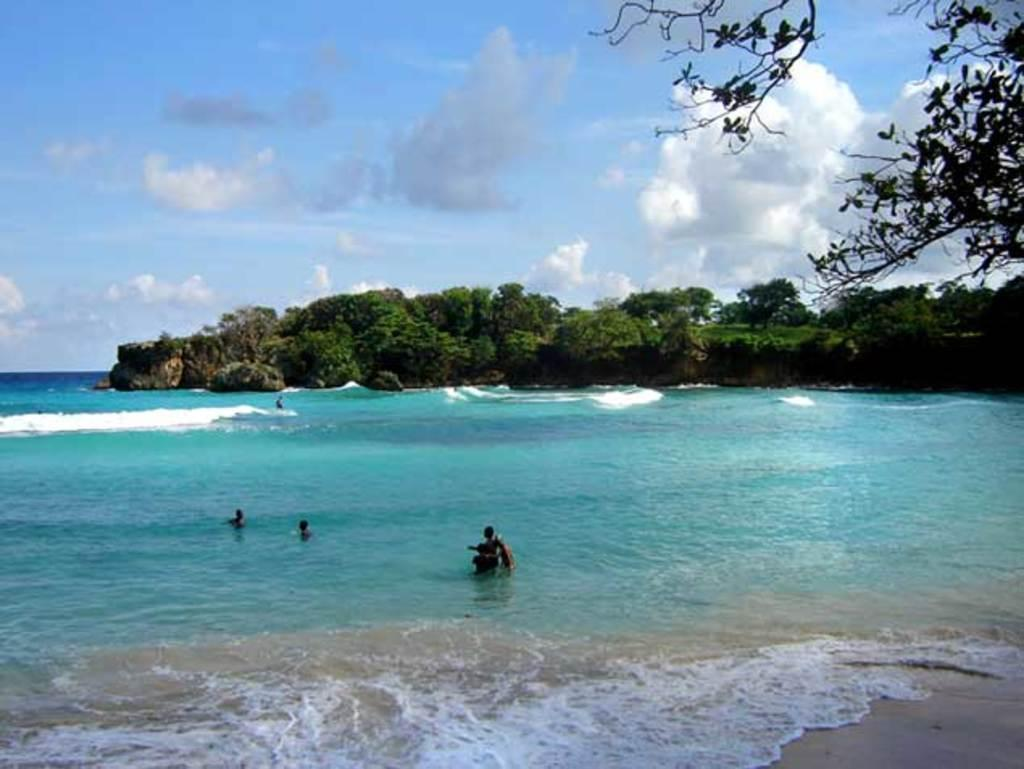What is the main subject of the image? The image depicts an ocean. What are the people in the image doing? There are people swimming in the ocean. What can be seen at the bottom of the image? There is water at the bottom of the image. What type of vegetation is visible in the background of the image? There are trees in the background of the image. What is visible at the top of the image? The sky is visible at the top of the image. What type of dinner is being served on the beach in the image? There is no dinner or beach present in the image; it depicts an ocean with people swimming. What is the quiver used for in the image? There is no quiver present in the image. 